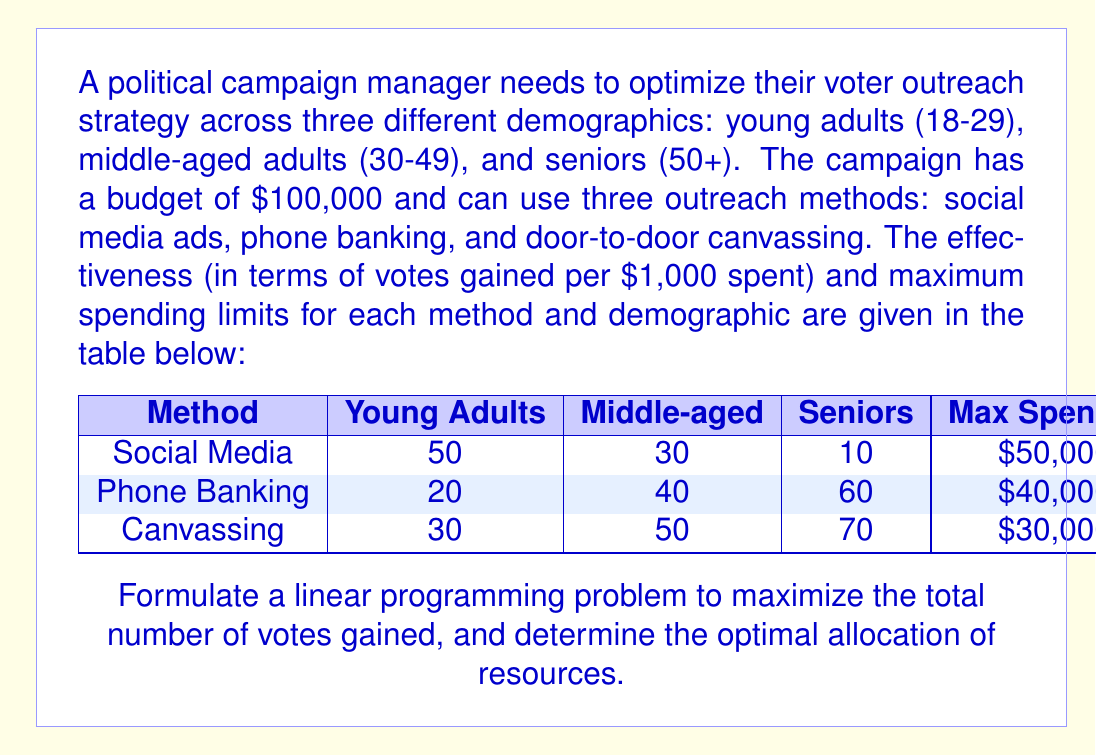Provide a solution to this math problem. To formulate this linear programming problem, we need to define our decision variables, objective function, and constraints.

1. Decision Variables:
Let $x_1$, $x_2$, and $x_3$ represent the amount (in thousands of dollars) spent on social media ads, phone banking, and canvassing respectively.

2. Objective Function:
We want to maximize the total number of votes gained. The objective function is:

$$\text{Maximize } Z = (50x_1 + 20x_2 + 30x_3) + (30x_1 + 40x_2 + 50x_3) + (10x_1 + 60x_2 + 70x_3)$$

Which simplifies to:
$$\text{Maximize } Z = 90x_1 + 120x_2 + 150x_3$$

3. Constraints:
a) Budget constraint: The total spending must not exceed $100,000
   $$x_1 + x_2 + x_3 \leq 100$$

b) Maximum spending limits for each method:
   $$x_1 \leq 50$$
   $$x_2 \leq 40$$
   $$x_3 \leq 30$$

c) Non-negativity constraints:
   $$x_1, x_2, x_3 \geq 0$$

The complete linear programming problem is:

$$
\begin{align*}
\text{Maximize } & Z = 90x_1 + 120x_2 + 150x_3 \\
\text{Subject to: } & x_1 + x_2 + x_3 \leq 100 \\
& x_1 \leq 50 \\
& x_2 \leq 40 \\
& x_3 \leq 30 \\
& x_1, x_2, x_3 \geq 0
\end{align*}
$$

To solve this problem, we can use the simplex method or a linear programming solver. The optimal solution is:

$$x_1 = 30, x_2 = 40, x_3 = 30$$

This means the campaign should spend:
- $30,000 on social media ads
- $40,000 on phone banking
- $30,000 on canvassing

The maximum number of votes gained with this allocation is:

$$Z = 90(30) + 120(40) + 150(30) = 10,500$$
Answer: The optimal resource allocation is:
- Social media ads: $30,000
- Phone banking: $40,000
- Canvassing: $30,000

This allocation will result in a maximum of 10,500 votes gained. 